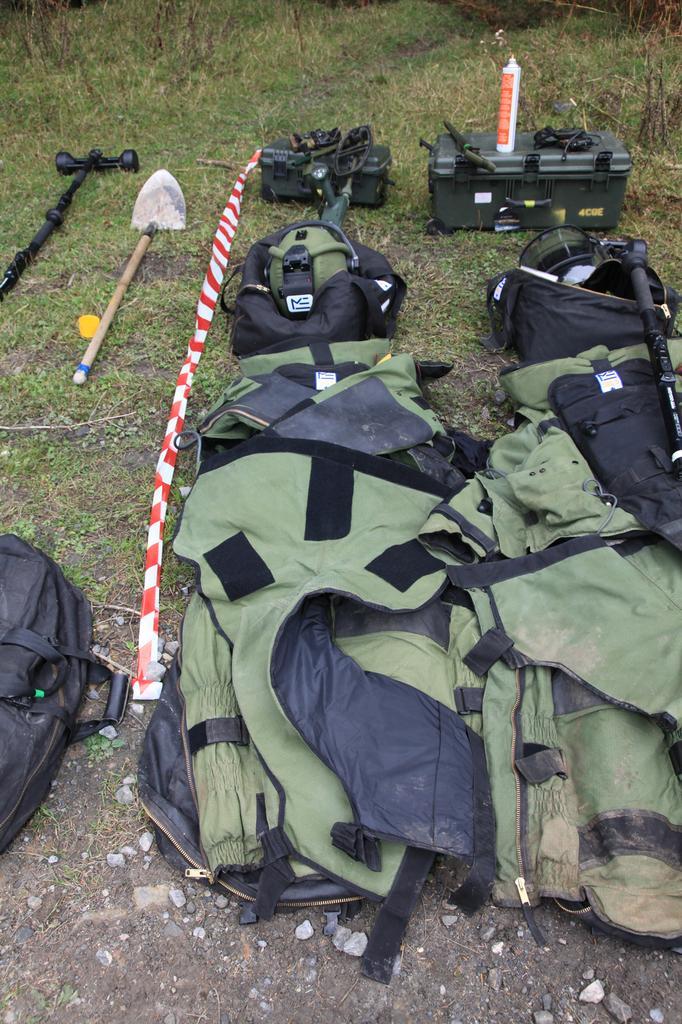How would you summarize this image in a sentence or two? This image is clicked outside. There are so many things in this image. There are bags, boxes, there is a stick and digging items on the left side top corner. There is a Grass on the top. There is some bottle on the box which is on the right side. 